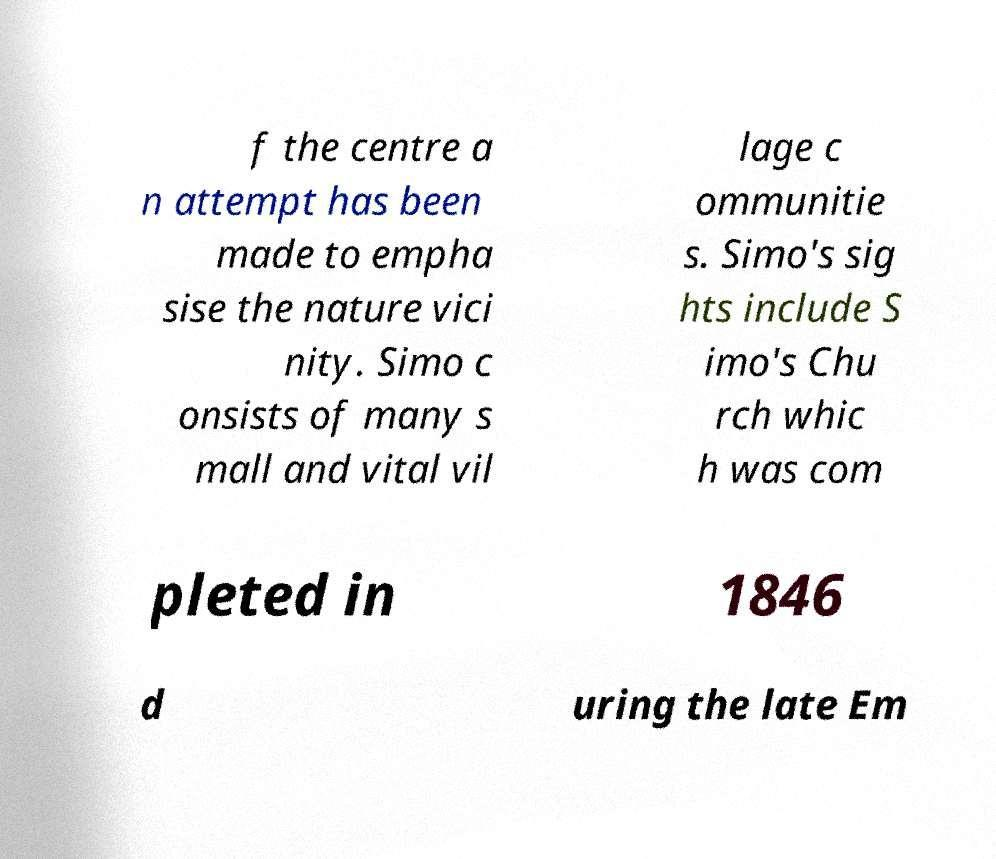I need the written content from this picture converted into text. Can you do that? f the centre a n attempt has been made to empha sise the nature vici nity. Simo c onsists of many s mall and vital vil lage c ommunitie s. Simo's sig hts include S imo's Chu rch whic h was com pleted in 1846 d uring the late Em 